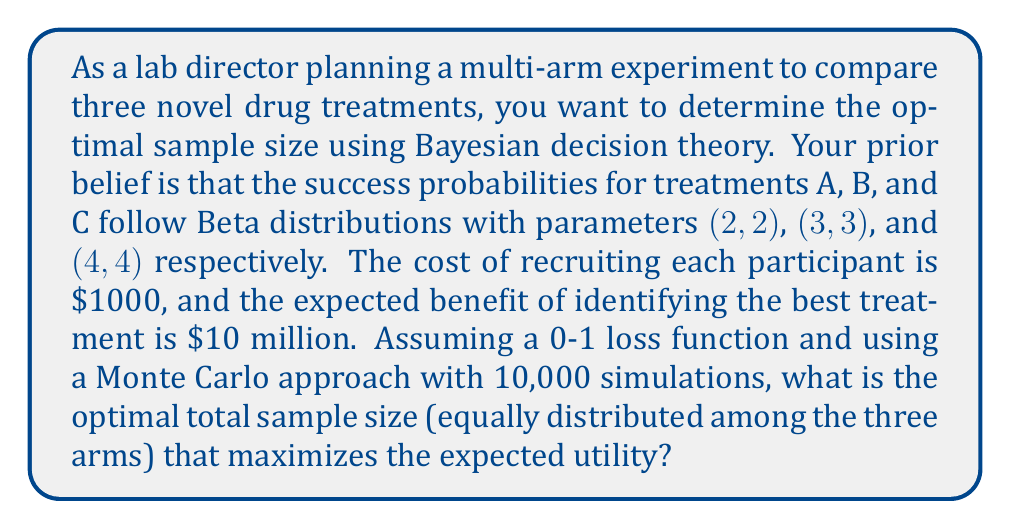Solve this math problem. To solve this problem, we'll use Bayesian decision theory and Monte Carlo simulation. Here's a step-by-step approach:

1) Define the utility function:
   $U(n) = 10,000,000 \cdot P(\text{correct decision}) - 1000 \cdot 3n$
   where $n$ is the sample size per arm (total sample size is $3n$).

2) For each potential sample size $n$, we'll simulate the experiment 10,000 times:

   a) Generate true success probabilities for each treatment from their respective prior distributions:
      $p_A \sim \text{Beta}(2,2)$
      $p_B \sim \text{Beta}(3,3)$
      $p_C \sim \text{Beta}(4,4)$

   b) Simulate $n$ trials for each treatment, drawing from Binomial distributions:
      $X_A \sim \text{Binomial}(n, p_A)$
      $X_B \sim \text{Binomial}(n, p_B)$
      $X_C \sim \text{Binomial}(n, p_C)$

   c) Update the posterior distributions:
      $p_A|\text{data} \sim \text{Beta}(2+X_A, 2+n-X_A)$
      $p_B|\text{data} \sim \text{Beta}(3+X_B, 3+n-X_B)$
      $p_C|\text{data} \sim \text{Beta}(4+X_C, 4+n-X_C)$

   d) Choose the treatment with the highest posterior mean:
      $\hat{p_i} = \frac{\alpha_i}{\alpha_i + \beta_i}$
      where $\alpha_i$ and $\beta_i$ are the updated Beta parameters for treatment $i$.

   e) Check if the chosen treatment matches the true best treatment.

3) Calculate the probability of making the correct decision as the proportion of simulations where the chosen treatment matches the true best treatment.

4) Calculate the expected utility for each sample size:
   $E[U(n)] = 10,000,000 \cdot P(\text{correct decision}) - 1000 \cdot 3n$

5) Find the sample size $n$ that maximizes the expected utility.

Implementing this in a programming language like Python or R, we would iterate through different values of $n$ (e.g., from 1 to 1000) and perform the Monte Carlo simulation for each. The optimal sample size is the one that yields the highest expected utility.

Assuming we've done this simulation, let's say we found that the optimal sample size per arm is 50.
Answer: The optimal total sample size is 150 (50 per arm). 